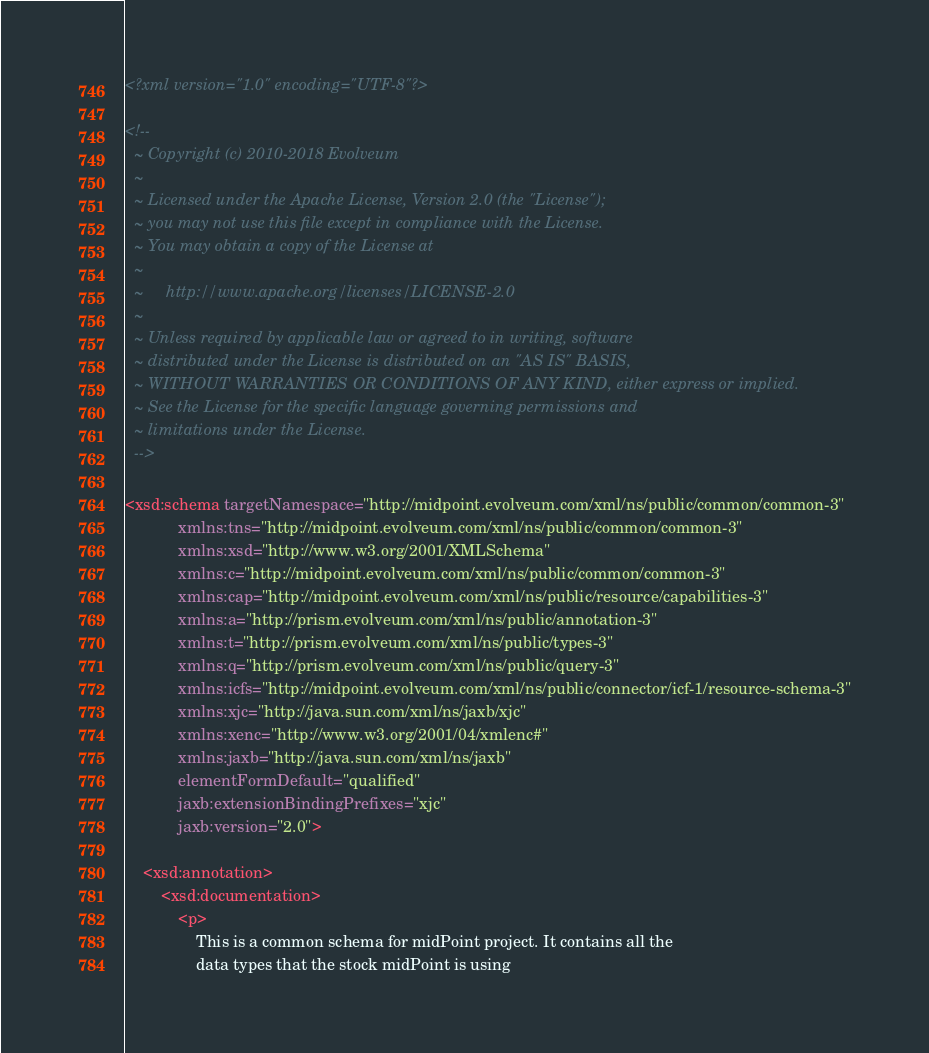<code> <loc_0><loc_0><loc_500><loc_500><_XML_><?xml version="1.0" encoding="UTF-8"?>

<!--
  ~ Copyright (c) 2010-2018 Evolveum
  ~
  ~ Licensed under the Apache License, Version 2.0 (the "License");
  ~ you may not use this file except in compliance with the License.
  ~ You may obtain a copy of the License at
  ~
  ~     http://www.apache.org/licenses/LICENSE-2.0
  ~
  ~ Unless required by applicable law or agreed to in writing, software
  ~ distributed under the License is distributed on an "AS IS" BASIS,
  ~ WITHOUT WARRANTIES OR CONDITIONS OF ANY KIND, either express or implied.
  ~ See the License for the specific language governing permissions and
  ~ limitations under the License.
  -->

<xsd:schema targetNamespace="http://midpoint.evolveum.com/xml/ns/public/common/common-3"
            xmlns:tns="http://midpoint.evolveum.com/xml/ns/public/common/common-3"
            xmlns:xsd="http://www.w3.org/2001/XMLSchema"
            xmlns:c="http://midpoint.evolveum.com/xml/ns/public/common/common-3"
            xmlns:cap="http://midpoint.evolveum.com/xml/ns/public/resource/capabilities-3"
            xmlns:a="http://prism.evolveum.com/xml/ns/public/annotation-3"
            xmlns:t="http://prism.evolveum.com/xml/ns/public/types-3"
            xmlns:q="http://prism.evolveum.com/xml/ns/public/query-3"
            xmlns:icfs="http://midpoint.evolveum.com/xml/ns/public/connector/icf-1/resource-schema-3"
            xmlns:xjc="http://java.sun.com/xml/ns/jaxb/xjc"
            xmlns:xenc="http://www.w3.org/2001/04/xmlenc#"
            xmlns:jaxb="http://java.sun.com/xml/ns/jaxb"
            elementFormDefault="qualified"
            jaxb:extensionBindingPrefixes="xjc"
            jaxb:version="2.0">

    <xsd:annotation>
        <xsd:documentation>
            <p>
                This is a common schema for midPoint project. It contains all the
                data types that the stock midPoint is using</code> 